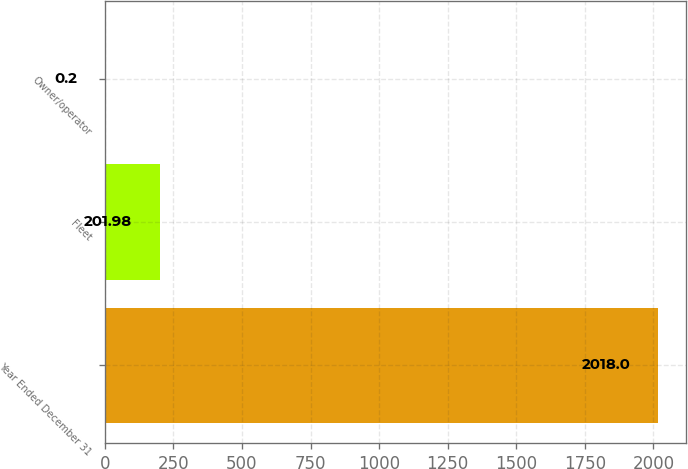Convert chart. <chart><loc_0><loc_0><loc_500><loc_500><bar_chart><fcel>Year Ended December 31<fcel>Fleet<fcel>Owner/operator<nl><fcel>2018<fcel>201.98<fcel>0.2<nl></chart> 